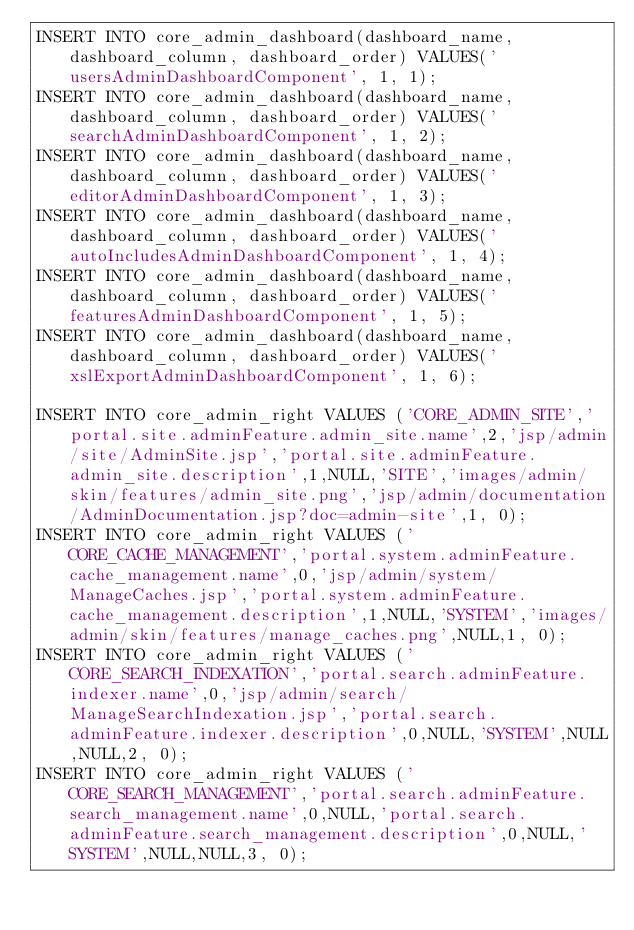<code> <loc_0><loc_0><loc_500><loc_500><_SQL_>INSERT INTO core_admin_dashboard(dashboard_name, dashboard_column, dashboard_order) VALUES('usersAdminDashboardComponent', 1, 1);
INSERT INTO core_admin_dashboard(dashboard_name, dashboard_column, dashboard_order) VALUES('searchAdminDashboardComponent', 1, 2);
INSERT INTO core_admin_dashboard(dashboard_name, dashboard_column, dashboard_order) VALUES('editorAdminDashboardComponent', 1, 3);
INSERT INTO core_admin_dashboard(dashboard_name, dashboard_column, dashboard_order) VALUES('autoIncludesAdminDashboardComponent', 1, 4);
INSERT INTO core_admin_dashboard(dashboard_name, dashboard_column, dashboard_order) VALUES('featuresAdminDashboardComponent', 1, 5);
INSERT INTO core_admin_dashboard(dashboard_name, dashboard_column, dashboard_order) VALUES('xslExportAdminDashboardComponent', 1, 6);

INSERT INTO core_admin_right VALUES ('CORE_ADMIN_SITE','portal.site.adminFeature.admin_site.name',2,'jsp/admin/site/AdminSite.jsp','portal.site.adminFeature.admin_site.description',1,NULL,'SITE','images/admin/skin/features/admin_site.png','jsp/admin/documentation/AdminDocumentation.jsp?doc=admin-site',1, 0);
INSERT INTO core_admin_right VALUES ('CORE_CACHE_MANAGEMENT','portal.system.adminFeature.cache_management.name',0,'jsp/admin/system/ManageCaches.jsp','portal.system.adminFeature.cache_management.description',1,NULL,'SYSTEM','images/admin/skin/features/manage_caches.png',NULL,1, 0);
INSERT INTO core_admin_right VALUES ('CORE_SEARCH_INDEXATION','portal.search.adminFeature.indexer.name',0,'jsp/admin/search/ManageSearchIndexation.jsp','portal.search.adminFeature.indexer.description',0,NULL,'SYSTEM',NULL,NULL,2, 0);
INSERT INTO core_admin_right VALUES ('CORE_SEARCH_MANAGEMENT','portal.search.adminFeature.search_management.name',0,NULL,'portal.search.adminFeature.search_management.description',0,NULL,'SYSTEM',NULL,NULL,3, 0);</code> 